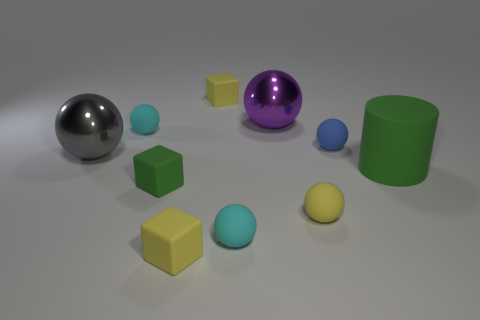There is a tiny ball that is on the left side of the purple thing and behind the big green cylinder; what color is it?
Provide a short and direct response. Cyan. There is a small green cube; what number of tiny rubber things are to the right of it?
Offer a very short reply. 5. What is the small green object made of?
Your answer should be very brief. Rubber. There is a large shiny thing left of the cube that is behind the big object to the left of the large purple object; what color is it?
Provide a succinct answer. Gray. How many red matte cubes have the same size as the yellow ball?
Provide a succinct answer. 0. What color is the big metallic thing that is right of the gray metal ball?
Your answer should be very brief. Purple. What number of other objects are there of the same size as the blue ball?
Ensure brevity in your answer.  6. There is a ball that is both to the right of the large purple object and behind the big green cylinder; how big is it?
Give a very brief answer. Small. There is a big rubber cylinder; is it the same color as the shiny sphere to the right of the big gray object?
Give a very brief answer. No. Are there any small green rubber things of the same shape as the purple metal object?
Offer a terse response. No. 